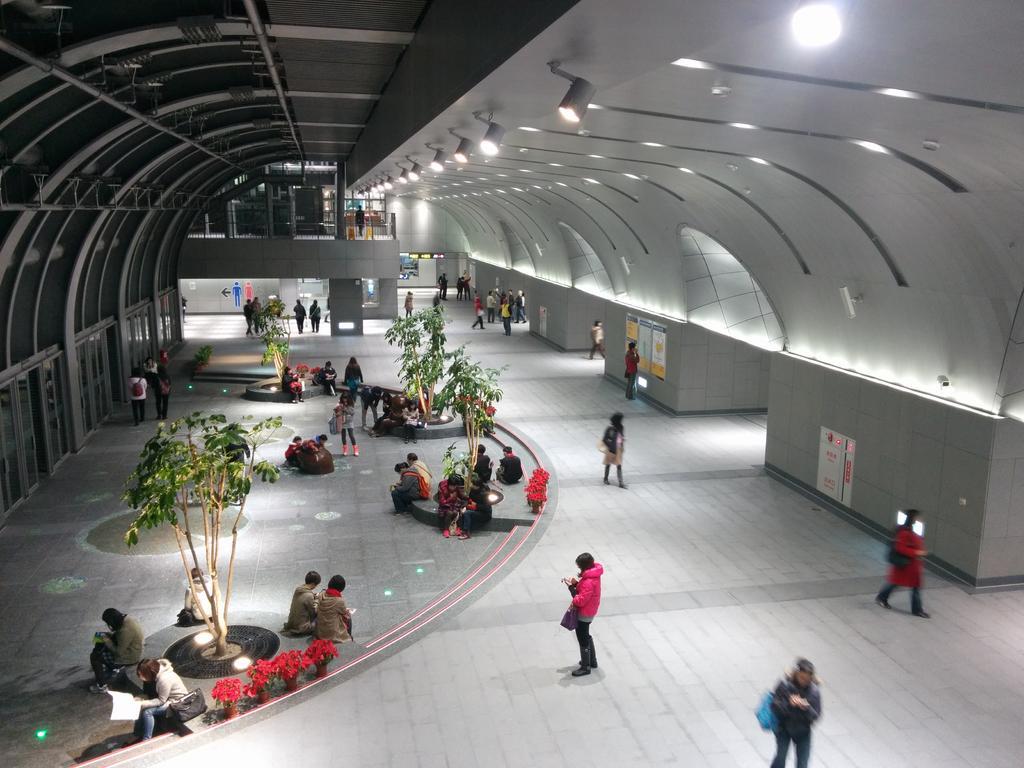How would you summarize this image in a sentence or two? In the image there are many people sitting and walking all over the floor, this is clicked inside a big hall, there are some plants on the left side, there are lights over the ceiling. 